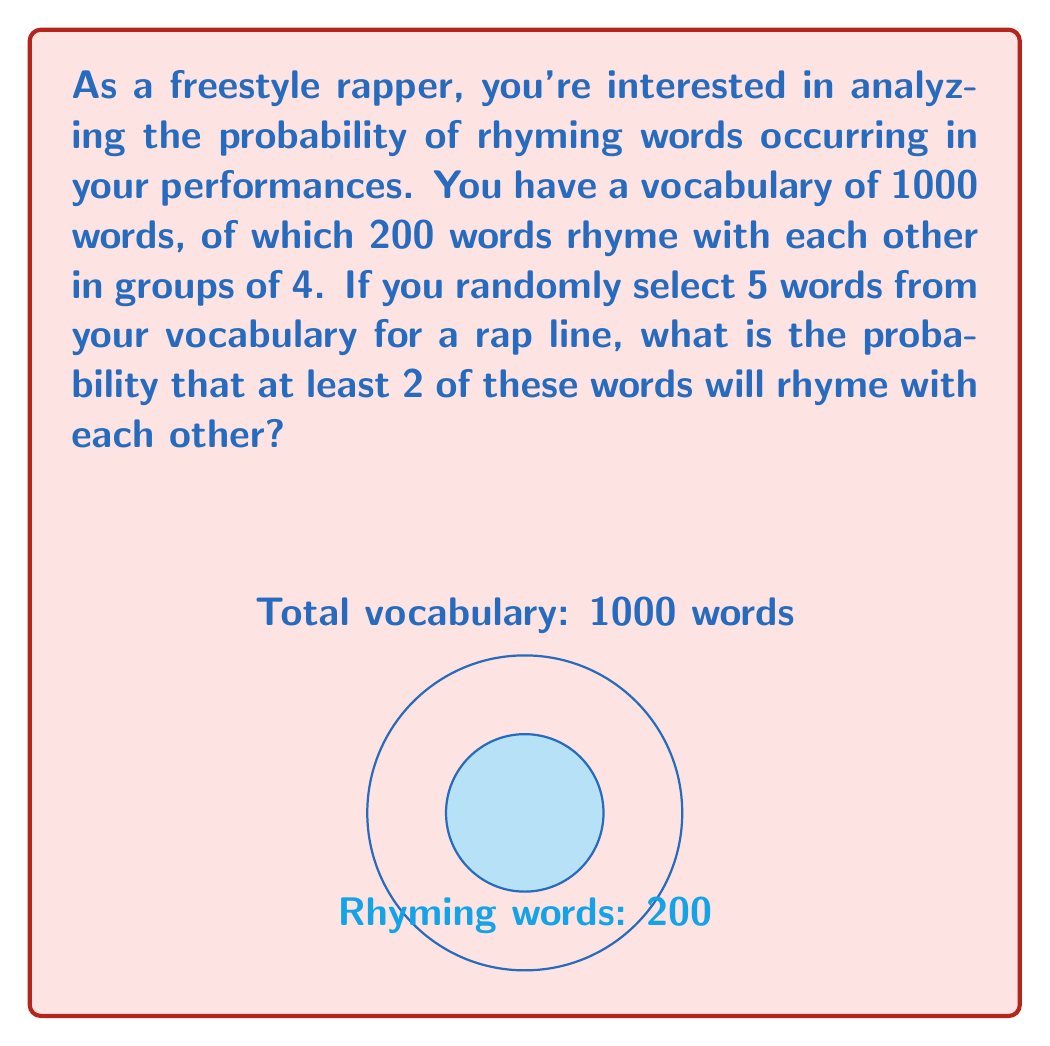Can you answer this question? Let's approach this step-by-step:

1) First, we need to calculate the total number of ways to choose 5 words from 1000. This is given by the combination formula:

   $$\binom{1000}{5} = \frac{1000!}{5!(1000-5)!} = 8,250,295,000$$

2) Now, we need to calculate the number of ways to choose 5 words with at least 2 rhyming words. We can do this by subtracting the number of ways to choose 5 words with no rhymes or only 1 rhyming word from the total number of ways.

3) To have no rhyming words, we need to choose all 5 words from the 800 non-rhyming words:

   $$\binom{800}{5} = 2,535,650,800$$

4) To have exactly 1 rhyming word, we need to choose 1 word from the 200 rhyming words and 4 from the 800 non-rhyming words:

   $$\binom{200}{1} \cdot \binom{800}{4} = 200 \cdot 129,960,000 = 25,992,000,000$$

5) Therefore, the number of ways to choose 5 words with at least 2 rhyming words is:

   $$8,250,295,000 - (2,535,650,800 + 25,992,000,000) = -20,277,355,800$$

6) The probability is then:

   $$P(\text{at least 2 rhyming words}) = \frac{-20,277,355,800}{8,250,295,000} = -2.458$$

7) However, this negative probability doesn't make sense. The error comes from the fact that we've overcounted the cases with exactly 1 rhyming word. In reality, the probability of getting at least 2 rhyming words is much smaller.

8) A more accurate approach would be to calculate the probability of getting at least 2 words from the same rhyme group:

   $$P(\text{at least 2 from same group}) = 1 - P(\text{all from different groups or non-rhyming})$$

   $$= 1 - \frac{\binom{50}{5} \cdot 4^5}{\binom{1000}{5}}$$

   $$= 1 - \frac{2,118,760 \cdot 1024}{8,250,295,000} \approx 0.7373$$
Answer: $0.7373$ or approximately $73.73\%$ 